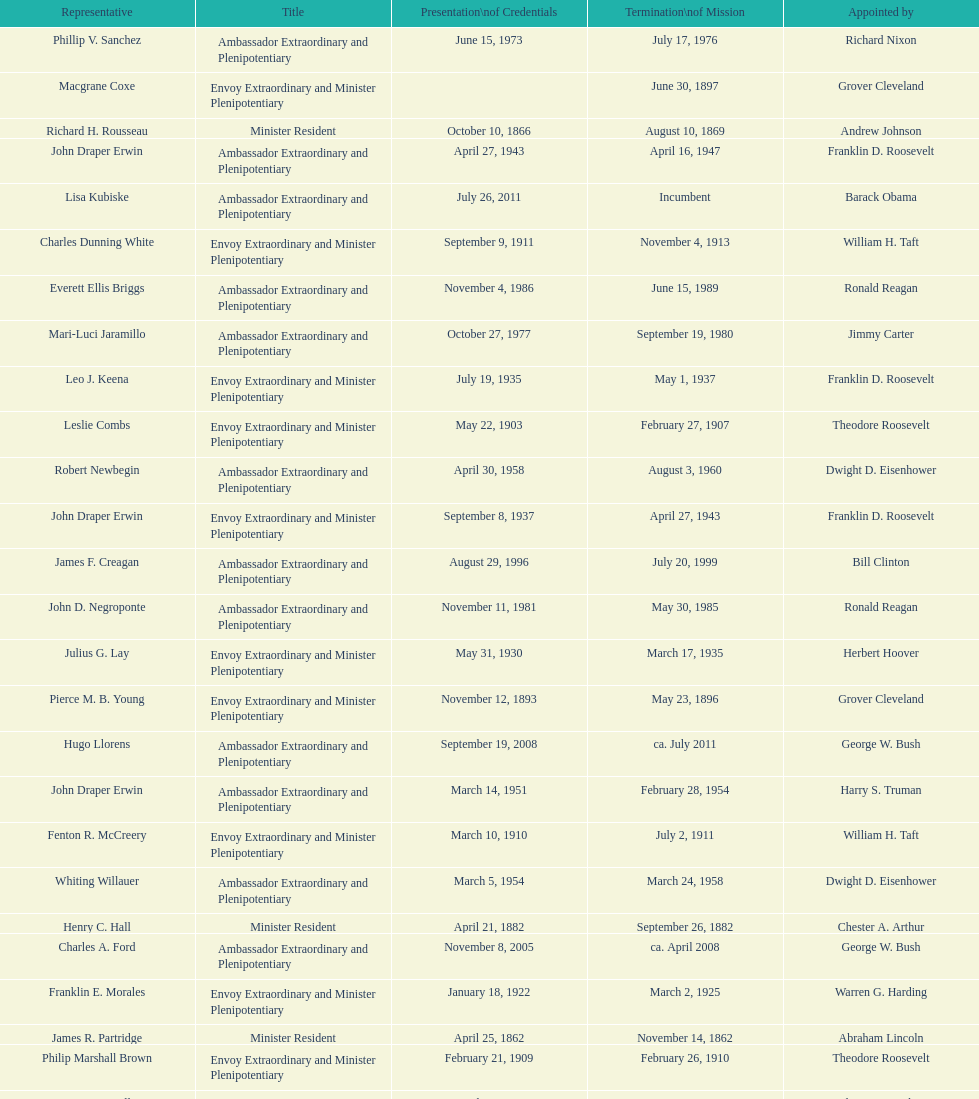Is solon borland a representative? Yes. 